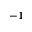Convert formula to latex. <formula><loc_0><loc_0><loc_500><loc_500>^ { - 1 }</formula> 